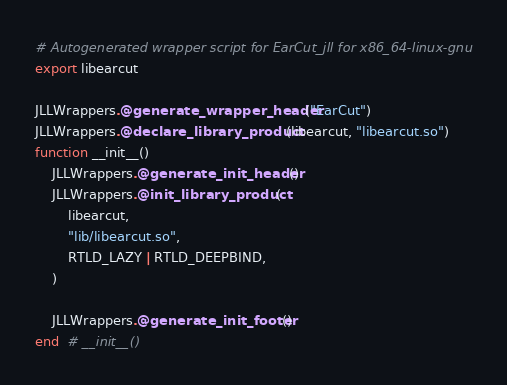<code> <loc_0><loc_0><loc_500><loc_500><_Julia_># Autogenerated wrapper script for EarCut_jll for x86_64-linux-gnu
export libearcut

JLLWrappers.@generate_wrapper_header("EarCut")
JLLWrappers.@declare_library_product(libearcut, "libearcut.so")
function __init__()
    JLLWrappers.@generate_init_header()
    JLLWrappers.@init_library_product(
        libearcut,
        "lib/libearcut.so",
        RTLD_LAZY | RTLD_DEEPBIND,
    )

    JLLWrappers.@generate_init_footer()
end  # __init__()
</code> 